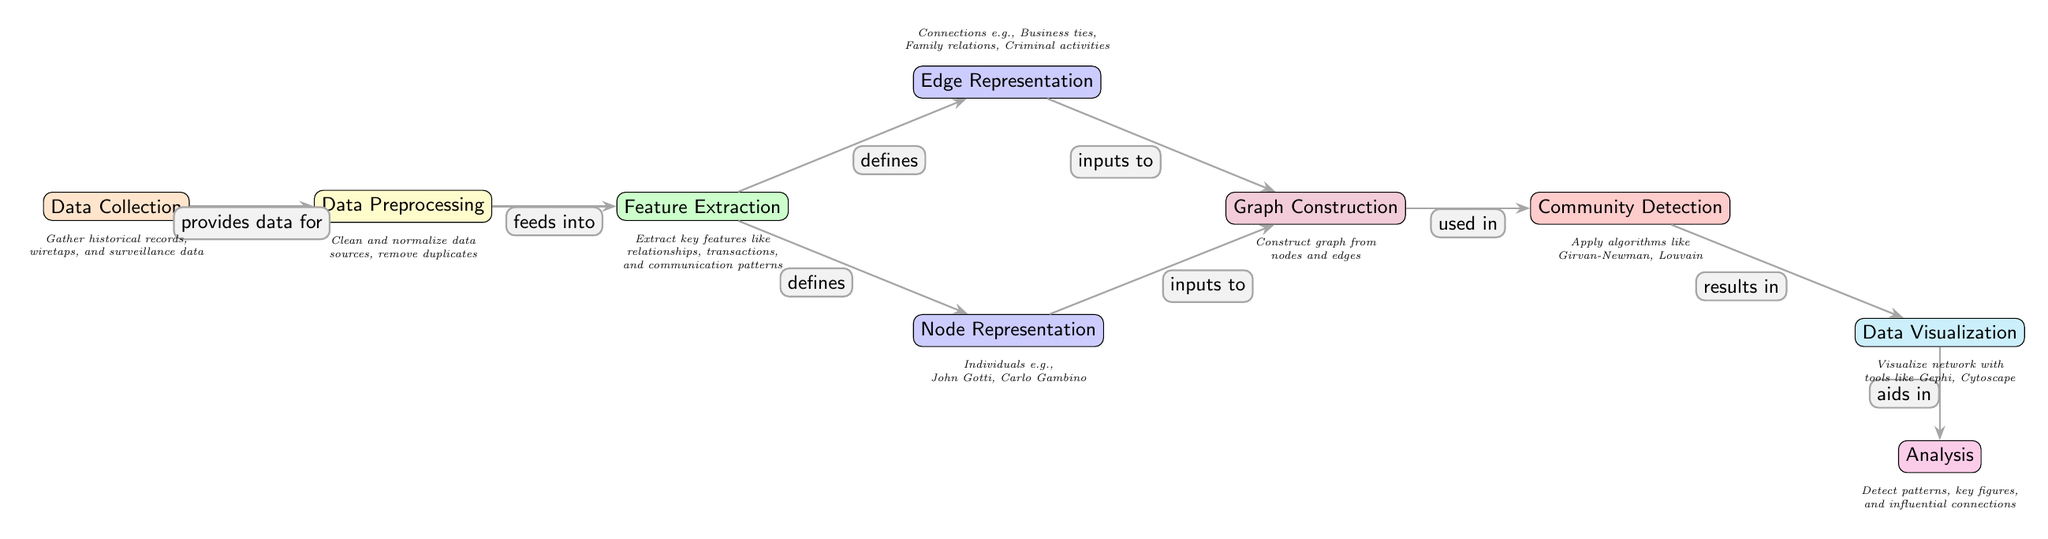What is the first step in the diagram? The first step is "Data Collection," which gathers historical records, wiretaps, and surveillance data as indicated in the diagram.
Answer: Data Collection How many main nodes are there in the diagram? The diagram contains nine main nodes, including "Data Collection," "Data Preprocessing," "Feature Extraction," "Node Representation," "Edge Representation," "Graph Construction," "Community Detection," "Data Visualization," and "Analysis."
Answer: 9 What does "Feature Extraction" define? "Feature Extraction" defines both "Node Representation" and "Edge Representation," connecting those nodes in the diagram.
Answer: Node Representation, Edge Representation Which node comes after "Graph Construction"? The node that comes after "Graph Construction" is "Community Detection," as indicated by the directional flow of the arrows in the diagram.
Answer: Community Detection What are the two types of representations defined by "Feature Extraction"? "Feature Extraction" defines "Node Representation" for individuals and "Edge Representation" for various connections, thereby distinguishing these two types.
Answer: Node Representation, Edge Representation Which algorithm is mentioned in the "Community Detection" node? The "Community Detection" node mentions algorithms like "Girvan-Newman" and "Louvain" as part of the community detection process.
Answer: Girvan-Newman, Louvain What does the "Data Visualization" node help to achieve? The "Data Visualization" node aids in the "Analysis" step, indicating that visualization results contribute to the overall analysis of the network.
Answer: Analysis What does the "Analysis" node detect? The "Analysis" node detects patterns, key figures, and influential connections as mentioned in its description below the node.
Answer: Patterns, key figures, influential connections 